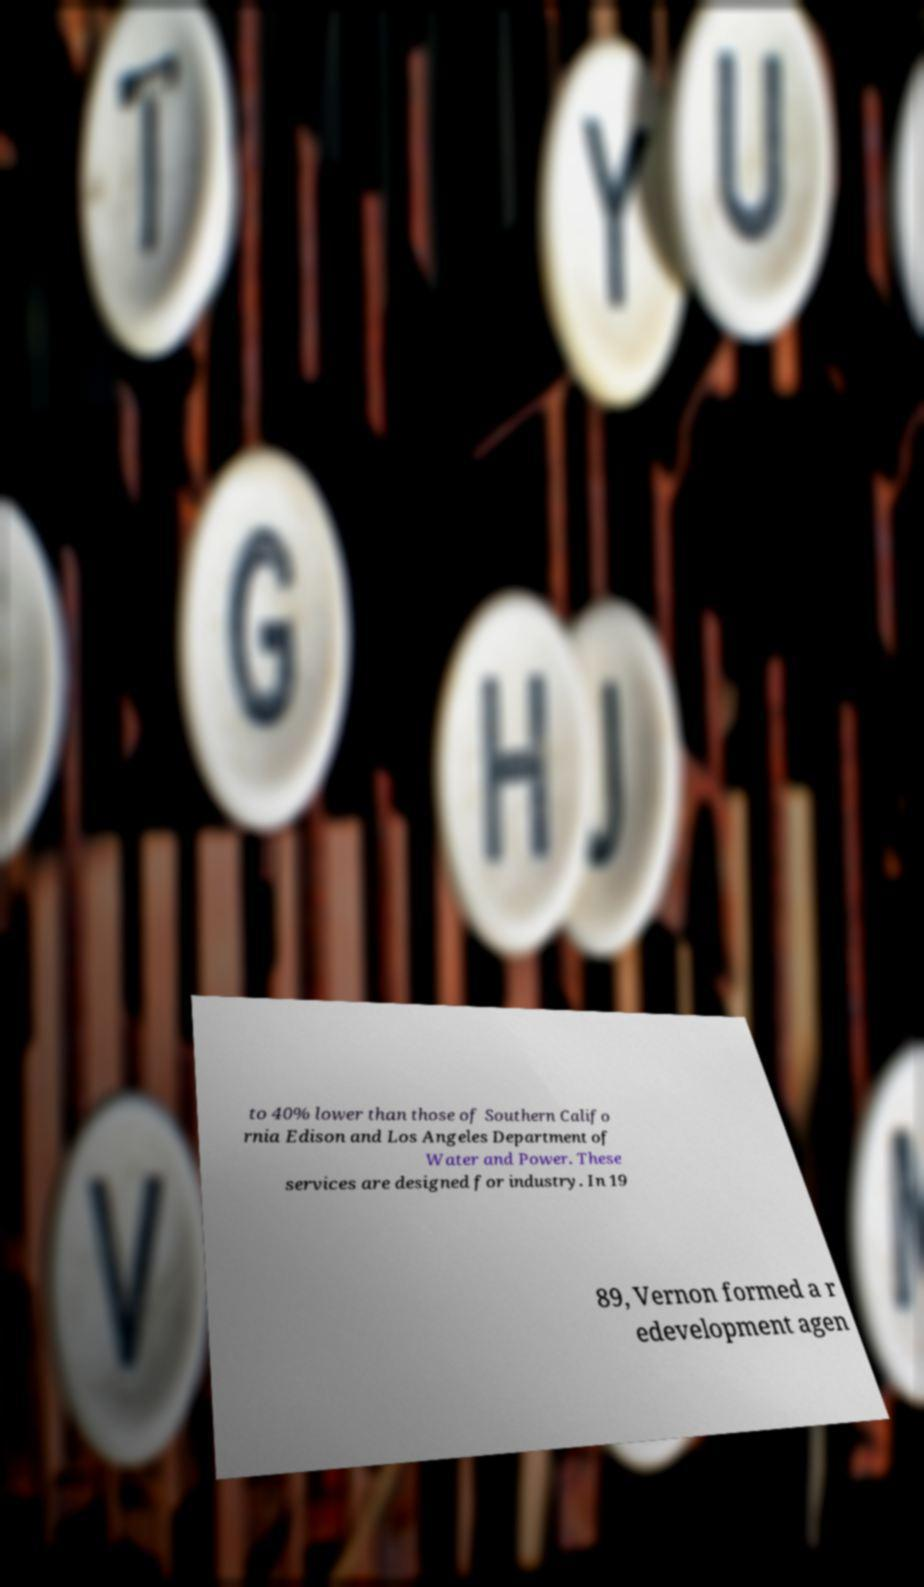Could you assist in decoding the text presented in this image and type it out clearly? to 40% lower than those of Southern Califo rnia Edison and Los Angeles Department of Water and Power. These services are designed for industry. In 19 89, Vernon formed a r edevelopment agen 